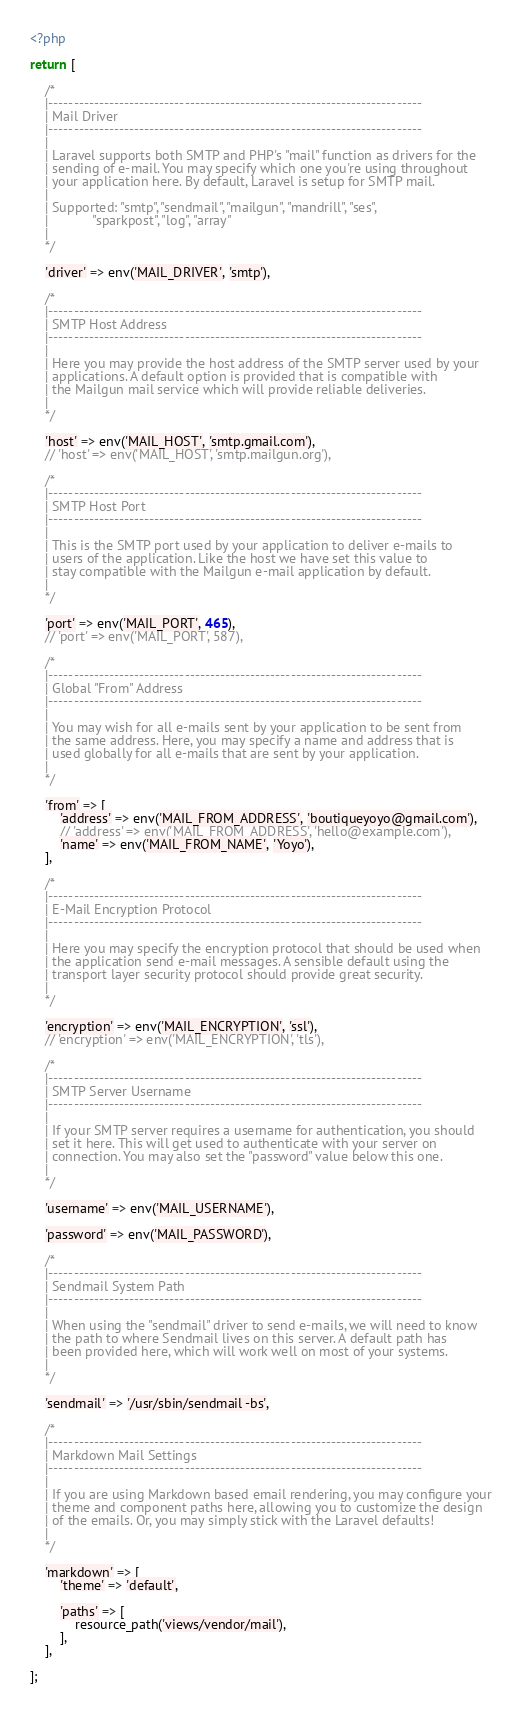Convert code to text. <code><loc_0><loc_0><loc_500><loc_500><_PHP_><?php

return [

    /*
    |--------------------------------------------------------------------------
    | Mail Driver
    |--------------------------------------------------------------------------
    |
    | Laravel supports both SMTP and PHP's "mail" function as drivers for the
    | sending of e-mail. You may specify which one you're using throughout
    | your application here. By default, Laravel is setup for SMTP mail.
    |
    | Supported: "smtp", "sendmail", "mailgun", "mandrill", "ses",
    |            "sparkpost", "log", "array"
    |
    */

    'driver' => env('MAIL_DRIVER', 'smtp'),

    /*
    |--------------------------------------------------------------------------
    | SMTP Host Address
    |--------------------------------------------------------------------------
    |
    | Here you may provide the host address of the SMTP server used by your
    | applications. A default option is provided that is compatible with
    | the Mailgun mail service which will provide reliable deliveries.
    |
    */

    'host' => env('MAIL_HOST', 'smtp.gmail.com'),
    // 'host' => env('MAIL_HOST', 'smtp.mailgun.org'),

    /*
    |--------------------------------------------------------------------------
    | SMTP Host Port
    |--------------------------------------------------------------------------
    |
    | This is the SMTP port used by your application to deliver e-mails to
    | users of the application. Like the host we have set this value to
    | stay compatible with the Mailgun e-mail application by default.
    |
    */

    'port' => env('MAIL_PORT', 465),
    // 'port' => env('MAIL_PORT', 587),

    /*
    |--------------------------------------------------------------------------
    | Global "From" Address
    |--------------------------------------------------------------------------
    |
    | You may wish for all e-mails sent by your application to be sent from
    | the same address. Here, you may specify a name and address that is
    | used globally for all e-mails that are sent by your application.
    |
    */

    'from' => [
        'address' => env('MAIL_FROM_ADDRESS', 'boutiqueyoyo@gmail.com'),
        // 'address' => env('MAIL_FROM_ADDRESS', 'hello@example.com'),
        'name' => env('MAIL_FROM_NAME', 'Yoyo'),
    ],

    /*
    |--------------------------------------------------------------------------
    | E-Mail Encryption Protocol
    |--------------------------------------------------------------------------
    |
    | Here you may specify the encryption protocol that should be used when
    | the application send e-mail messages. A sensible default using the
    | transport layer security protocol should provide great security.
    |
    */

    'encryption' => env('MAIL_ENCRYPTION', 'ssl'),
    // 'encryption' => env('MAIL_ENCRYPTION', 'tls'),

    /*
    |--------------------------------------------------------------------------
    | SMTP Server Username
    |--------------------------------------------------------------------------
    |
    | If your SMTP server requires a username for authentication, you should
    | set it here. This will get used to authenticate with your server on
    | connection. You may also set the "password" value below this one.
    |
    */

    'username' => env('MAIL_USERNAME'),

    'password' => env('MAIL_PASSWORD'),

    /*
    |--------------------------------------------------------------------------
    | Sendmail System Path
    |--------------------------------------------------------------------------
    |
    | When using the "sendmail" driver to send e-mails, we will need to know
    | the path to where Sendmail lives on this server. A default path has
    | been provided here, which will work well on most of your systems.
    |
    */

    'sendmail' => '/usr/sbin/sendmail -bs',

    /*
    |--------------------------------------------------------------------------
    | Markdown Mail Settings
    |--------------------------------------------------------------------------
    |
    | If you are using Markdown based email rendering, you may configure your
    | theme and component paths here, allowing you to customize the design
    | of the emails. Or, you may simply stick with the Laravel defaults!
    |
    */

    'markdown' => [
        'theme' => 'default',

        'paths' => [
            resource_path('views/vendor/mail'),
        ],
    ],

];
</code> 